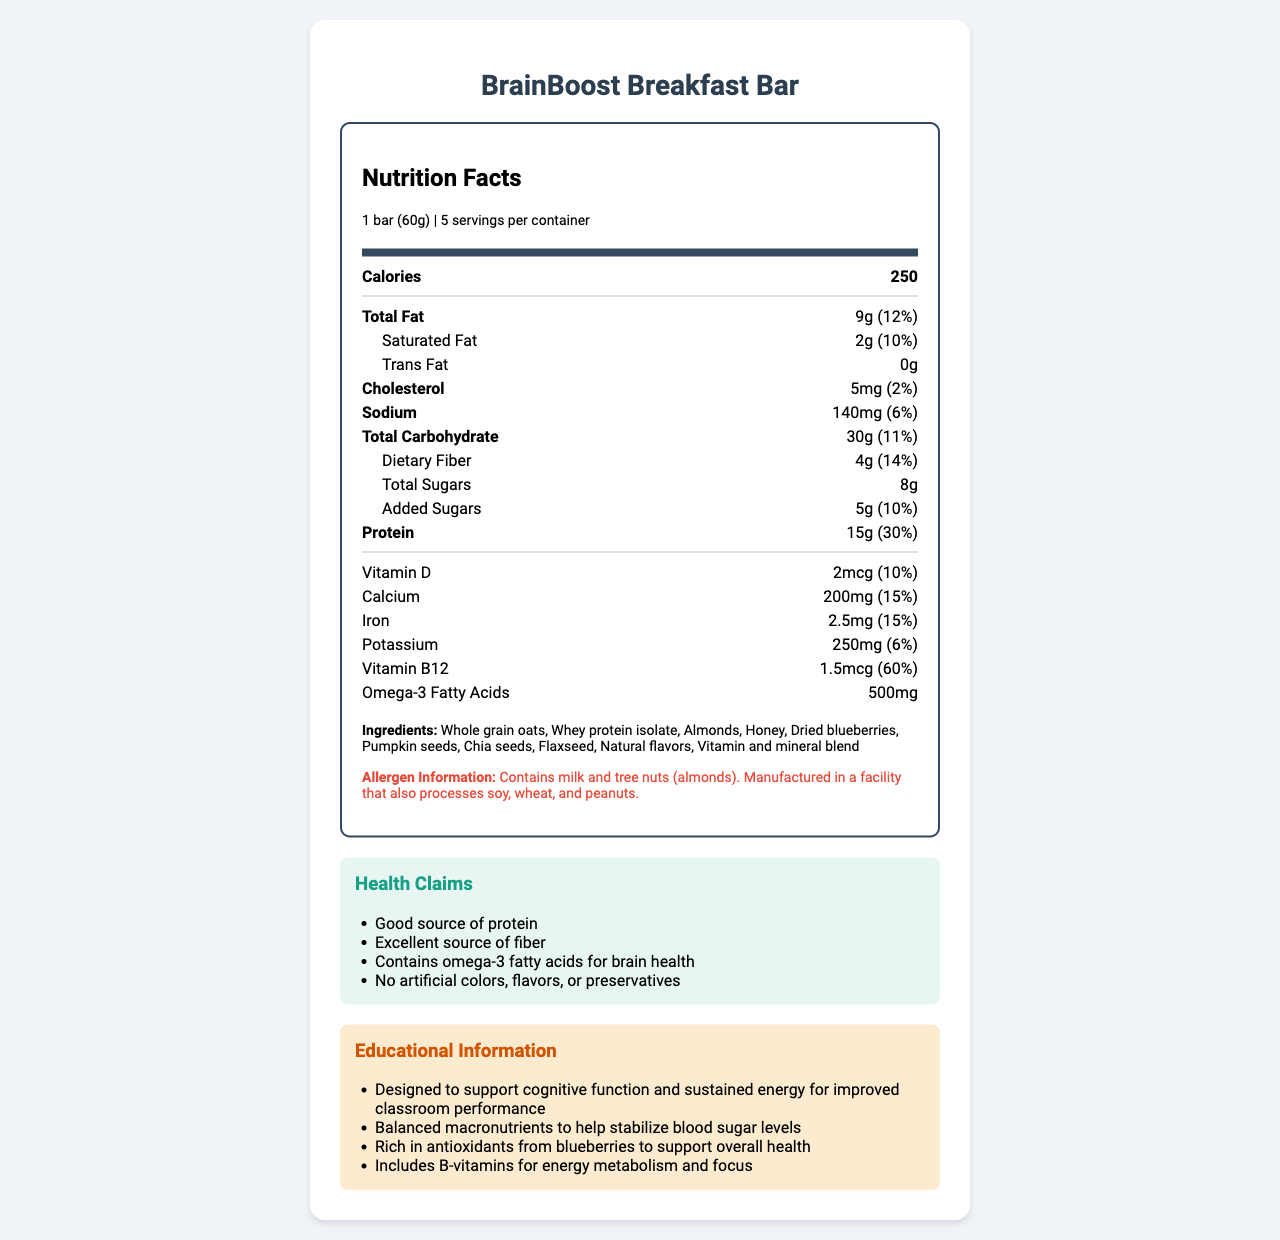what is the serving size of the BrainBoost Breakfast Bar? The label indicates that the serving size is explicitly mentioned as 1 bar, which weighs 60 grams.
Answer: 1 bar (60g) how many calories are in one serving of the BrainBoost Breakfast Bar? The label shows that each serving contains 250 calories.
Answer: 250 how much protein does one serving of the BrainBoost Breakfast Bar provide? According to the nutrition facts, one serving provides 15 grams of protein.
Answer: 15g what is the daily value percentage for vitamin B12 per serving? The label lists vitamin B12 with a daily value percentage of 60%.
Answer: 60% how many grams of dietary fiber are in each serving? The nutrition facts indicate that each serving contains 4 grams of dietary fiber.
Answer: 4g what is the main ingredient in the BrainBoost Breakfast Bar? A. Honey B. Almonds C. Whole grain oats D. Dried blueberries Whole grain oats are the first listed ingredient, indicating they are the main ingredient.
Answer: C what is the total fat content per serving, and how does it compare to the daily value percentage? A. 9g, 10% B. 8g, 12% C. 10g, 11% D. 9g, 12% The label states that the total fat content is 9 grams, which is 12% of the daily value.
Answer: D does the BrainBoost Breakfast Bar contain any trans fat? The label shows that the trans fat content is 0 grams, indicating it contains no trans fat.
Answer: No is the information provided sufficient to determine whether the breakfast bar is gluten-free? The document does not specify whether the product is gluten-free. It mentions allergens like soy, wheat, and peanuts in the facility, but it doesn’t classify the product as gluten-free.
Answer: Not enough information summarize the purpose and key nutritional aspects of the BrainBoost Breakfast Bar. This summary captures the main purpose, serving size, key macronutrients, and specific benefits of the BrainBoost Breakfast Bar, also highlighting some primary ingredients and health benefits described in the document.
Answer: The BrainBoost Breakfast Bar is a protein-rich snack designed to improve student focus and concentration. One serving size is 1 bar (60g), and it offers balanced macronutrients such as 250 calories, 15g of protein, 30g of carbohydrates, and 9g of fat. It contains omega-3 fatty acids beneficial for brain health and vitamins like B12 and D to support cognitive function. The bar includes ingredients like whole grain oats, whey protein isolate, almonds, and dried blueberries, promoting overall health and sustained energy. 